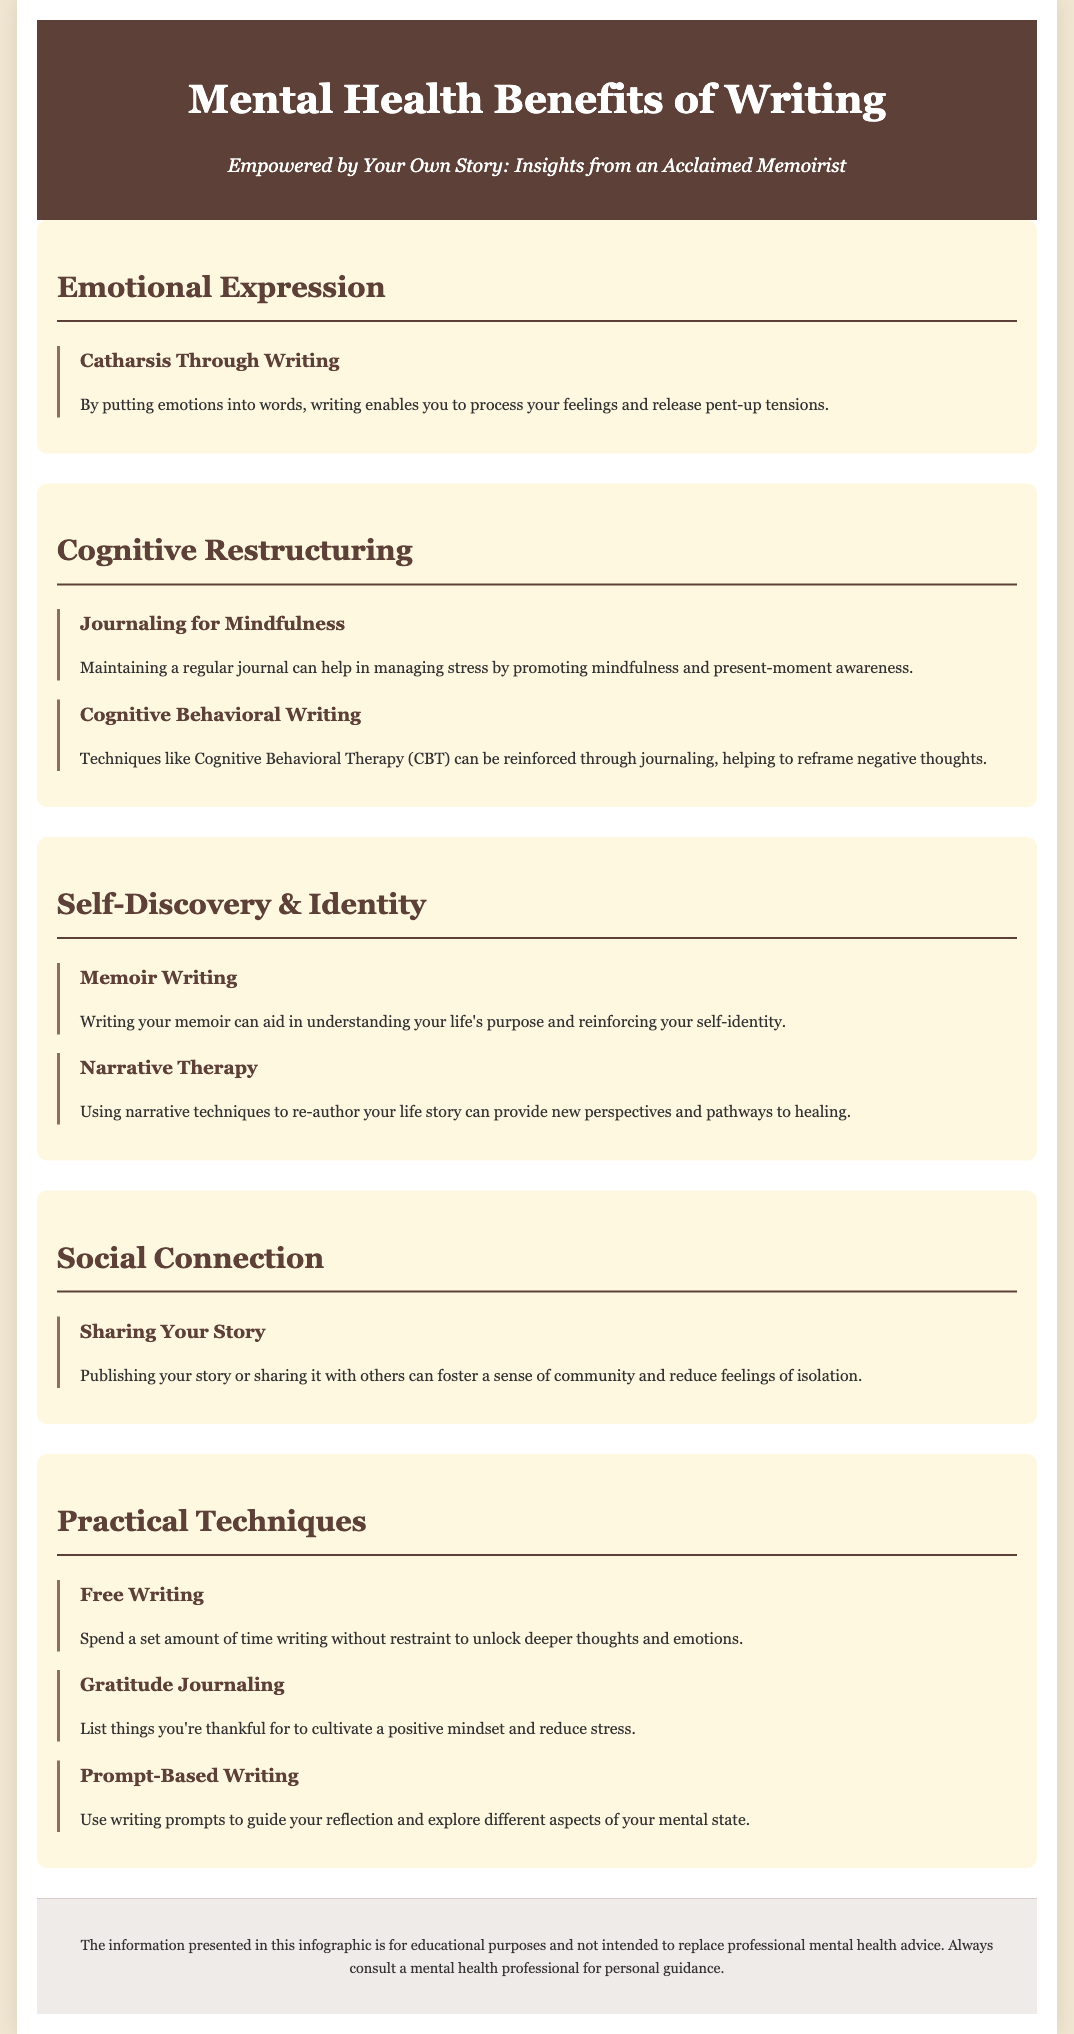What is the title of the document? The title of the document is prominently displayed at the top and reflects the main topic, which is about the benefits of writing for mental health.
Answer: Mental Health Benefits of Writing What technique promotes mindfulness? This technique involves maintaining a regular journal to help manage stress, as stated in the Cognitive Restructuring section.
Answer: Journaling for Mindfulness In which section is "Memoir Writing" discussed? The discussion about "Memoir Writing" is found in the section that focuses on self-discovery and identity.
Answer: Self-Discovery & Identity What writing technique helps unlock deeper thoughts? This technique encourages writing without restraint for a specific amount of time to tap into deeper emotions and thoughts.
Answer: Free Writing Which practice fosters community and reduces isolation? The act of sharing your personal story, whether by publishing or sharing it with others, is mentioned to foster community and reduce feelings of isolation.
Answer: Sharing Your Story What is the main purpose of the document? The overall purpose of the document is provided in the subtitle, centering around insights from an acclaimed memoirist about empowerment through story.
Answer: Insights from an Acclaimed Memoirist How many practical techniques are mentioned? The document enumerates specific practical techniques for writing, appearing in their respective section about techniques.
Answer: Three Which emotional benefit does writing provide through catharsis? This benefit is explained as the process of putting one's emotions into words to help process feelings and release tensions.
Answer: Catharsis Through Writing What type of therapy can be reinforced through journaling? This type of therapy helps reframe negative thoughts and is specifically mentioned in the document.
Answer: Cognitive Behavioral Therapy (CBT) 